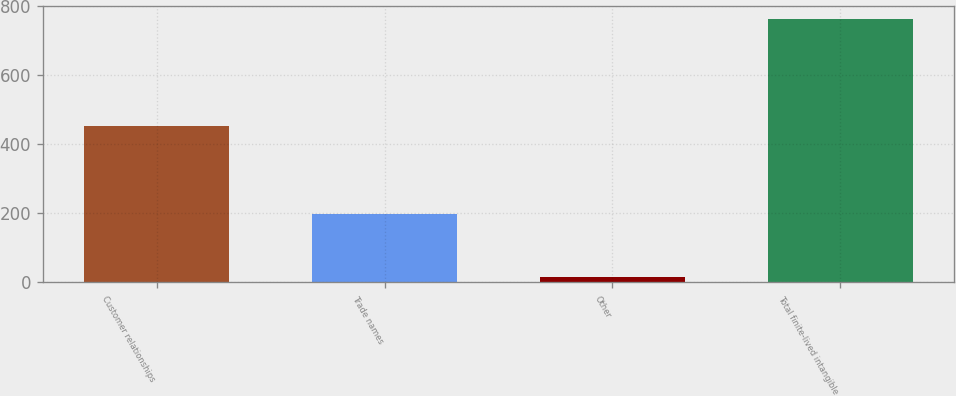Convert chart to OTSL. <chart><loc_0><loc_0><loc_500><loc_500><bar_chart><fcel>Customer relationships<fcel>Trade names<fcel>Other<fcel>Total finite-lived intangible<nl><fcel>452<fcel>199<fcel>17<fcel>763<nl></chart> 